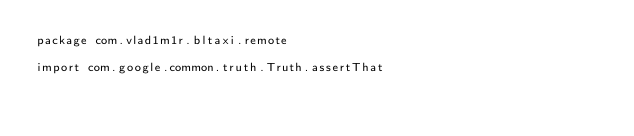<code> <loc_0><loc_0><loc_500><loc_500><_Kotlin_>package com.vlad1m1r.bltaxi.remote

import com.google.common.truth.Truth.assertThat</code> 